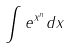<formula> <loc_0><loc_0><loc_500><loc_500>\int e ^ { x ^ { n } } d x</formula> 